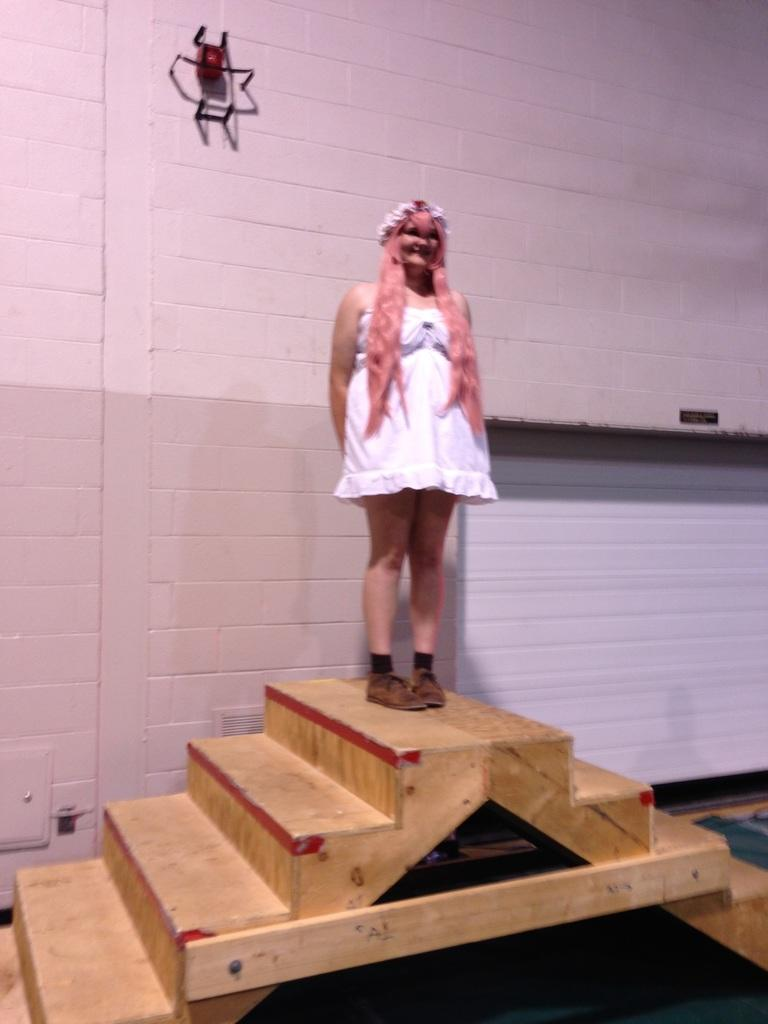Who is the main subject in the image? There is a woman in the image. What is the woman wearing? The woman is wearing a white skirt. Where is the woman standing? The woman is standing on a staircase. What can be seen behind the woman? There is a wall visible behind the woman. What is the woman's facial expression? The woman is smiling. How many eyes does the squirrel have in the image? There is no squirrel present in the image. Who is the creator of the woman in the image? The provided facts do not mention the creator of the woman in the image. 